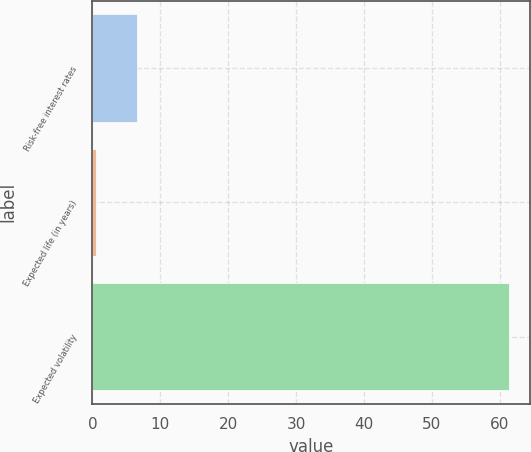<chart> <loc_0><loc_0><loc_500><loc_500><bar_chart><fcel>Risk-free interest rates<fcel>Expected life (in years)<fcel>Expected volatility<nl><fcel>6.59<fcel>0.5<fcel>61.4<nl></chart> 